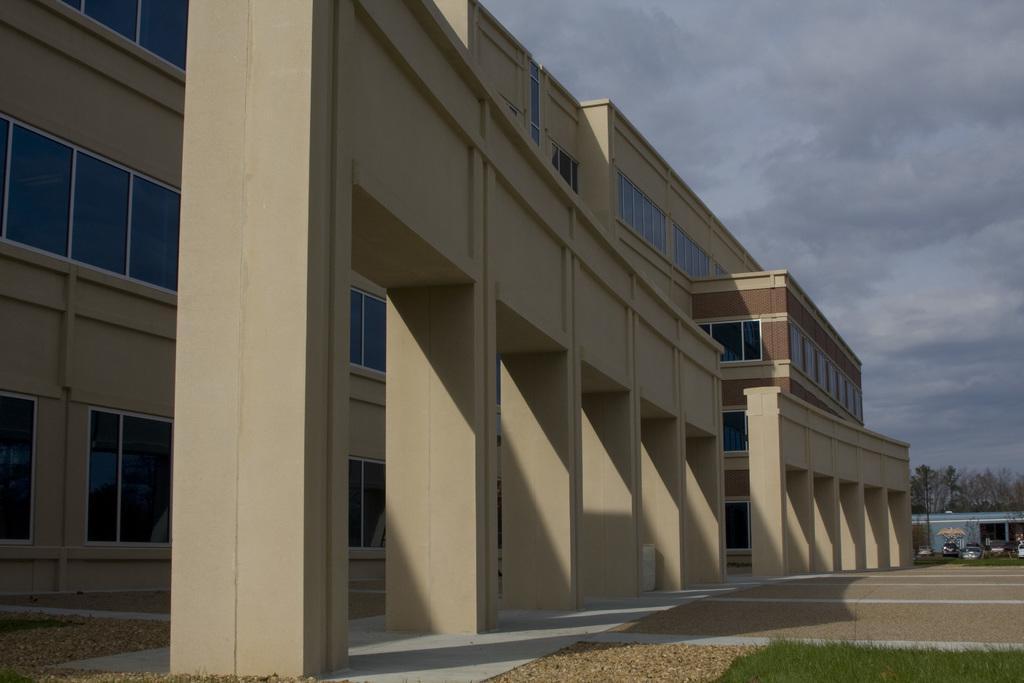Describe this image in one or two sentences. As we can see in the image there are buildings, grass, cars, trees, sky and clouds. 